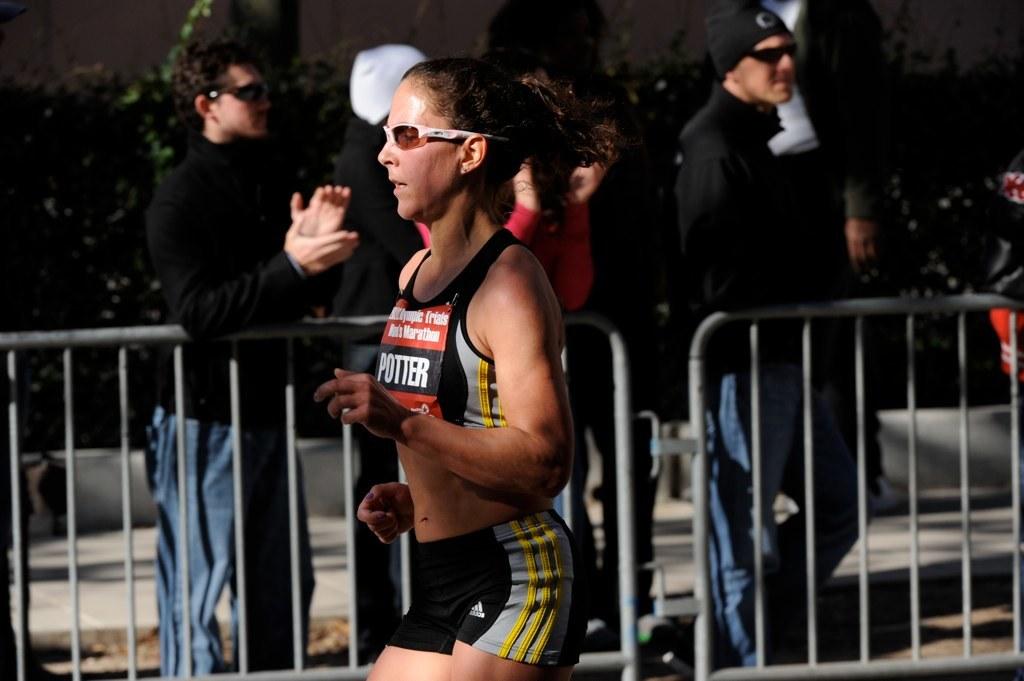What brand is this runner's shorts?
Offer a very short reply. Adidas. 